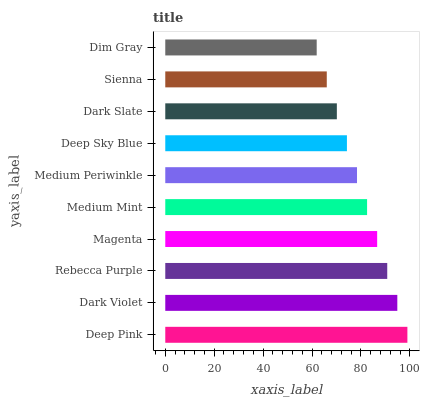Is Dim Gray the minimum?
Answer yes or no. Yes. Is Deep Pink the maximum?
Answer yes or no. Yes. Is Dark Violet the minimum?
Answer yes or no. No. Is Dark Violet the maximum?
Answer yes or no. No. Is Deep Pink greater than Dark Violet?
Answer yes or no. Yes. Is Dark Violet less than Deep Pink?
Answer yes or no. Yes. Is Dark Violet greater than Deep Pink?
Answer yes or no. No. Is Deep Pink less than Dark Violet?
Answer yes or no. No. Is Medium Mint the high median?
Answer yes or no. Yes. Is Medium Periwinkle the low median?
Answer yes or no. Yes. Is Rebecca Purple the high median?
Answer yes or no. No. Is Medium Mint the low median?
Answer yes or no. No. 